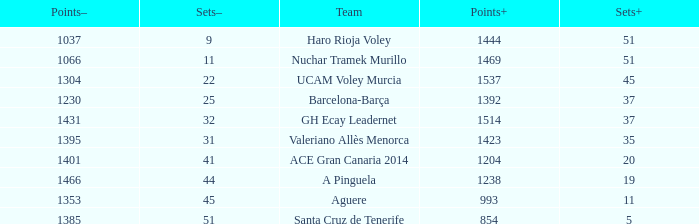What is the highest Points+ number when the Points- number is larger than 1385, a Sets+ number smaller than 37 and a Sets- number larger than 41? 1238.0. 